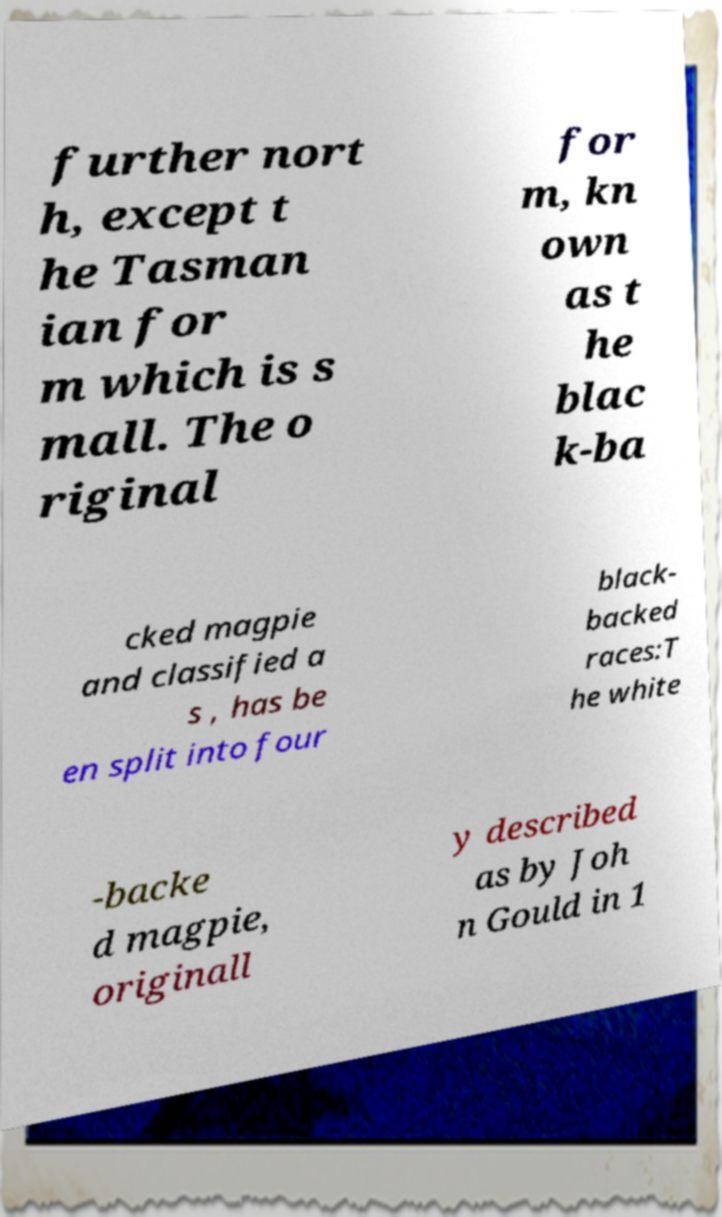There's text embedded in this image that I need extracted. Can you transcribe it verbatim? further nort h, except t he Tasman ian for m which is s mall. The o riginal for m, kn own as t he blac k-ba cked magpie and classified a s , has be en split into four black- backed races:T he white -backe d magpie, originall y described as by Joh n Gould in 1 